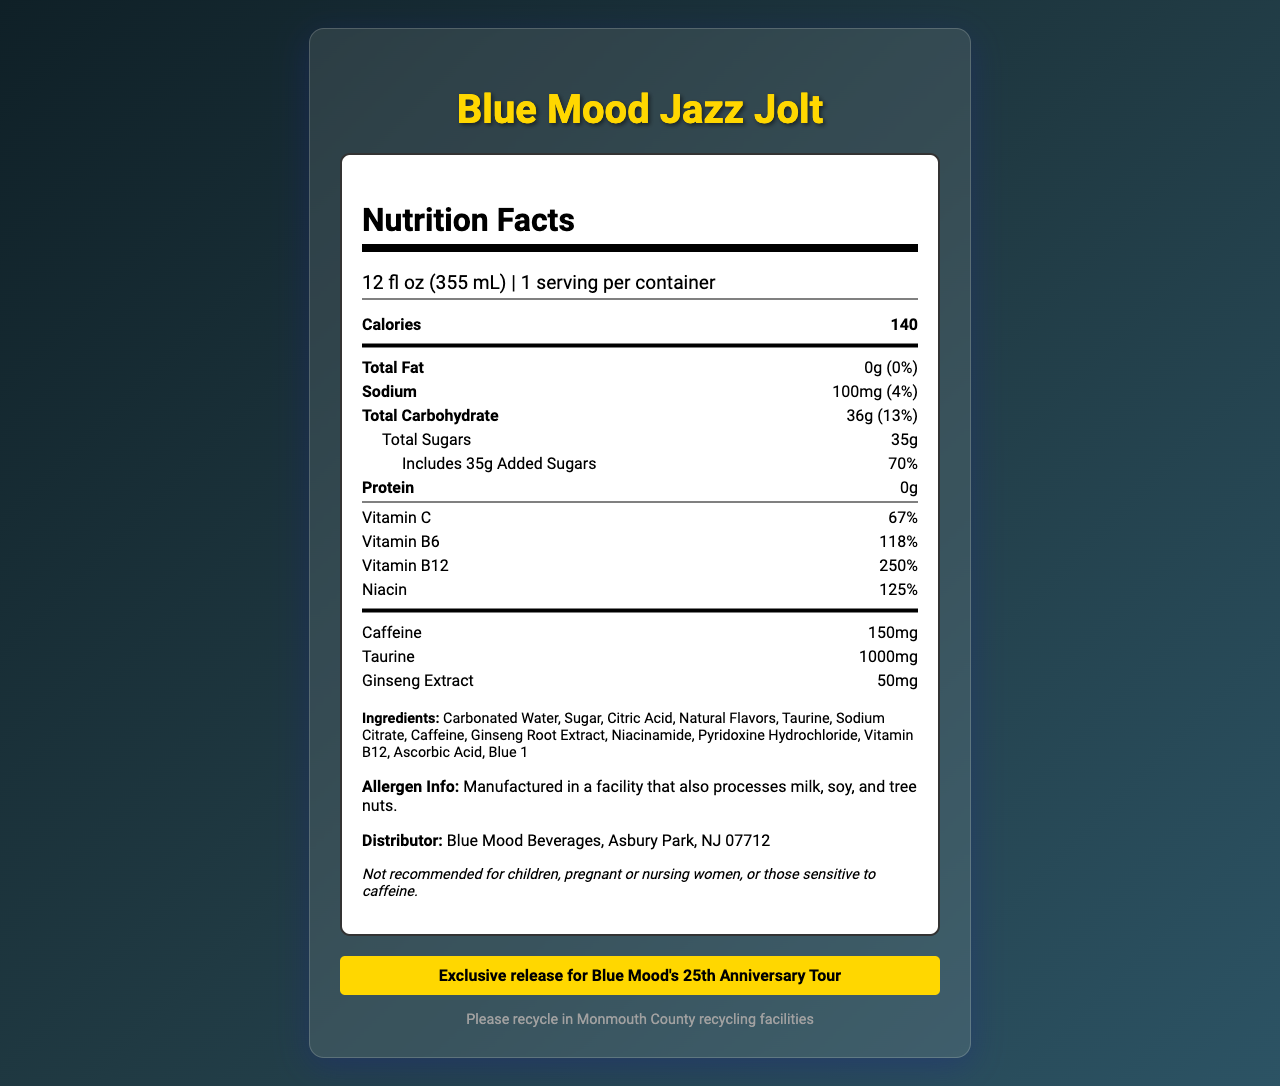What is the serving size of Blue Mood Jazz Jolt? The serving size is clearly listed at the top of the Nutrition Facts label.
Answer: 12 fl oz (355 mL) How many calories are in one serving of Blue Mood Jazz Jolt? The amount of calories per serving is prominently displayed under the 'Calories' section of the Nutrition Facts label.
Answer: 140 What percentage of the daily value of vitamin B12 does Blue Mood Jazz Jolt provide? This information is found under the vitamins section, where vitamin B12 is listed with its daily value percentage.
Answer: 250% How much sodium does the Blue Mood Jazz Jolt contain? The sodium content is specified under the 'Sodium' nutrient along with its daily value percentage.
Answer: 100mg What is the daily value percentage of added sugars in Blue Mood Jazz Jolt? This detail is provided under the total sugars section, where the added sugars and their daily value are clearly noted.
Answer: 70% Is the Blue Mood Jazz Jolt recommended for children or pregnant women? The disclaimer on the Nutrition Facts label specifically mentions that it is not recommended for children or pregnant/nursing women.
Answer: No Which of the following vitamins has the highest daily percentage value in Blue Mood Jazz Jolt?
A. Vitamin C
B. Vitamin B6
C. Vitamin B12
D. Niacin The daily value for vitamin B12 is 250%, which is higher than the percentages for vitamin C (67%), vitamin B6 (118%), and niacin (125%).
Answer: C. Vitamin B12 How much caffeine is in one serving of Blue Mood Jazz Jolt?
A. 100mg
B. 150mg
C. 200mg The caffeine content is clearly listed as 150mg on the Nutrition Facts label.
Answer: B. 150mg What is the total carbohydrate content in Blue Mood Jazz Jolt? This information is listed under the 'Total Carbohydrate' section on the Nutrition Facts label.
Answer: 36g Summarize the information found on the label of Blue Mood Jazz Jolt. This explanation covers all the main nutritional details, ingredients, allergen info, disclaimer, and recycling tips mentioned on the label.
Answer: The Blue Mood Jazz Jolt is a limited edition energy drink with a serving size of 12 fl oz and 140 calories per serving. It contains 0g fat, 100mg sodium, 36g total carbs, 35g total sugars (including 35g added sugars), and 0g protein. It also provides significant daily values of vitamin C (67%), vitamin B6 (118%), vitamin B12 (250%), and niacin (125%). Additionally, it has 150mg of caffeine, 1000mg of taurine, and 50mg of ginseng extract. The ingredients include carbonated water, sugar, citric acid, natural flavors, and more. There is an allergen info, a disclaimer recommending it not for children or pregnant/nursing women, and recycling info relevant to Monmouth County. What is the main ingredient in Blue Mood Jazz Jolt? The ingredients list shows carbonated water as the first ingredient, indicating it is the main component by volume.
Answer: Carbonated Water Can the origin of the ingredients used in Blue Mood Jazz Jolt be determined from the document? The document lists the ingredients but does not provide any information about their origin or source.
Answer: Cannot be determined 